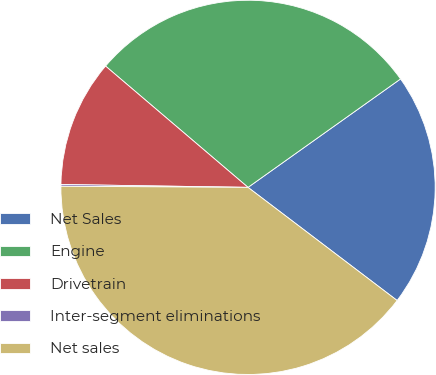Convert chart to OTSL. <chart><loc_0><loc_0><loc_500><loc_500><pie_chart><fcel>Net Sales<fcel>Engine<fcel>Drivetrain<fcel>Inter-segment eliminations<fcel>Net sales<nl><fcel>20.17%<fcel>28.94%<fcel>10.98%<fcel>0.15%<fcel>39.77%<nl></chart> 